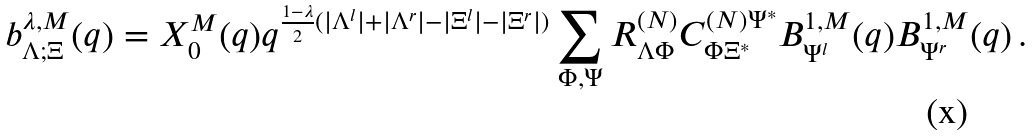<formula> <loc_0><loc_0><loc_500><loc_500>b ^ { \lambda , M } _ { \Lambda ; \Xi } ( q ) = X ^ { M } _ { 0 } ( q ) q ^ { \frac { 1 - \lambda } { 2 } ( | \Lambda ^ { l } | + | \Lambda ^ { r } | - | \Xi ^ { l } | - | \Xi ^ { r } | ) } \sum _ { \Phi , \Psi } R ^ { ( N ) } _ { \Lambda \Phi } C ^ { ( N ) \Psi ^ { * } } _ { \Phi \Xi ^ { * } } B ^ { 1 , M } _ { \Psi ^ { l } } ( q ) B ^ { 1 , M } _ { \Psi ^ { r } } ( q ) \, .</formula> 